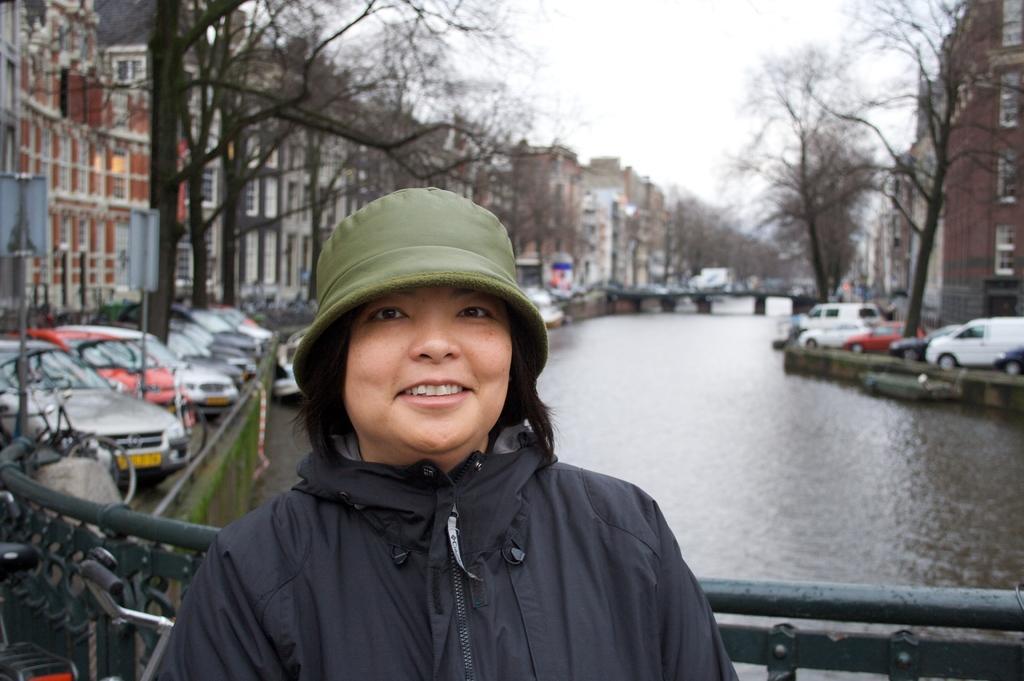Could you give a brief overview of what you see in this image? In this image a person wearing a black jacket is having a cap. Left bottom there is a bicycle. Behind it there is a fence. Left side there are few cars on the land having few trees and poles with the boards are on it. Middle of image there is a bridge. Right side there are few vehicles on the road. Under the bridge there is water. Background there are few trees, behind there are few buildings. Top of image there is sky. 